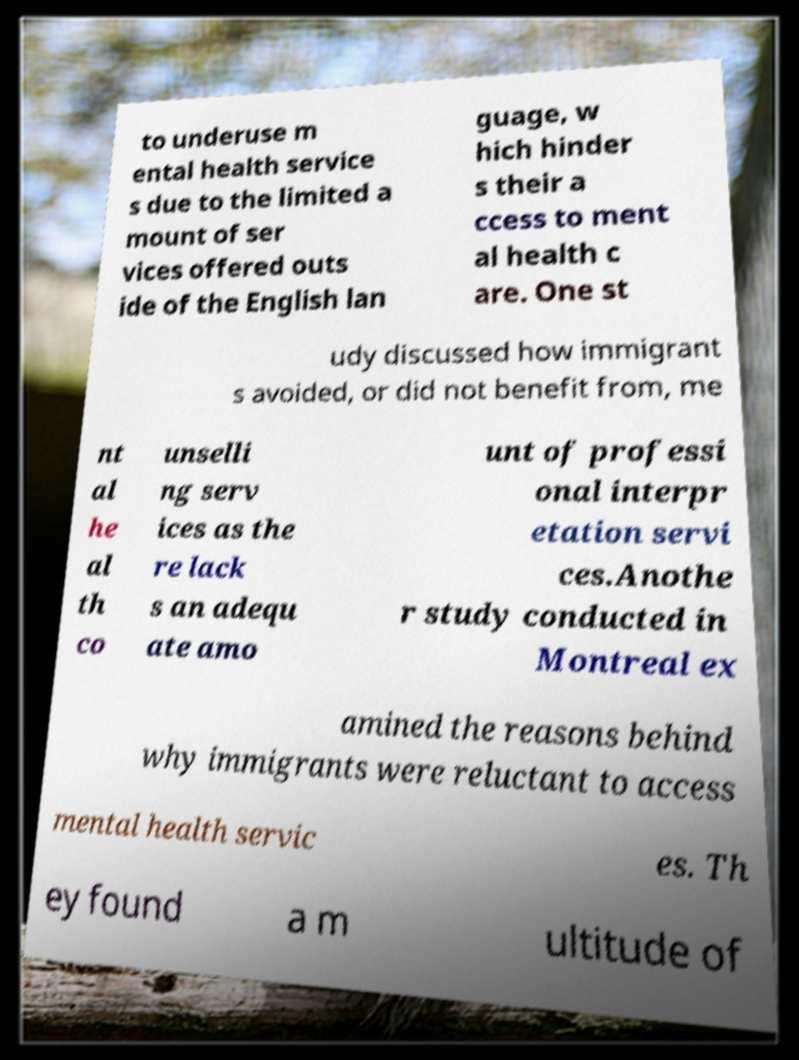What messages or text are displayed in this image? I need them in a readable, typed format. to underuse m ental health service s due to the limited a mount of ser vices offered outs ide of the English lan guage, w hich hinder s their a ccess to ment al health c are. One st udy discussed how immigrant s avoided, or did not benefit from, me nt al he al th co unselli ng serv ices as the re lack s an adequ ate amo unt of professi onal interpr etation servi ces.Anothe r study conducted in Montreal ex amined the reasons behind why immigrants were reluctant to access mental health servic es. Th ey found a m ultitude of 